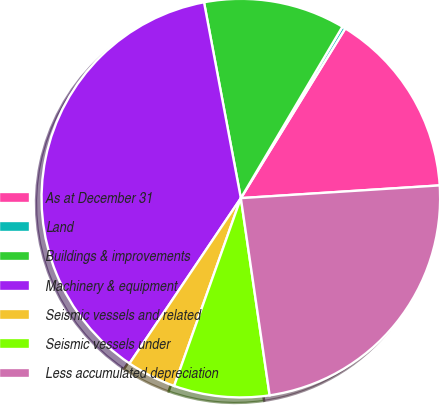<chart> <loc_0><loc_0><loc_500><loc_500><pie_chart><fcel>As at December 31<fcel>Land<fcel>Buildings & improvements<fcel>Machinery & equipment<fcel>Seismic vessels and related<fcel>Seismic vessels under<fcel>Less accumulated depreciation<nl><fcel>15.2%<fcel>0.27%<fcel>11.47%<fcel>37.61%<fcel>4.0%<fcel>7.74%<fcel>23.71%<nl></chart> 